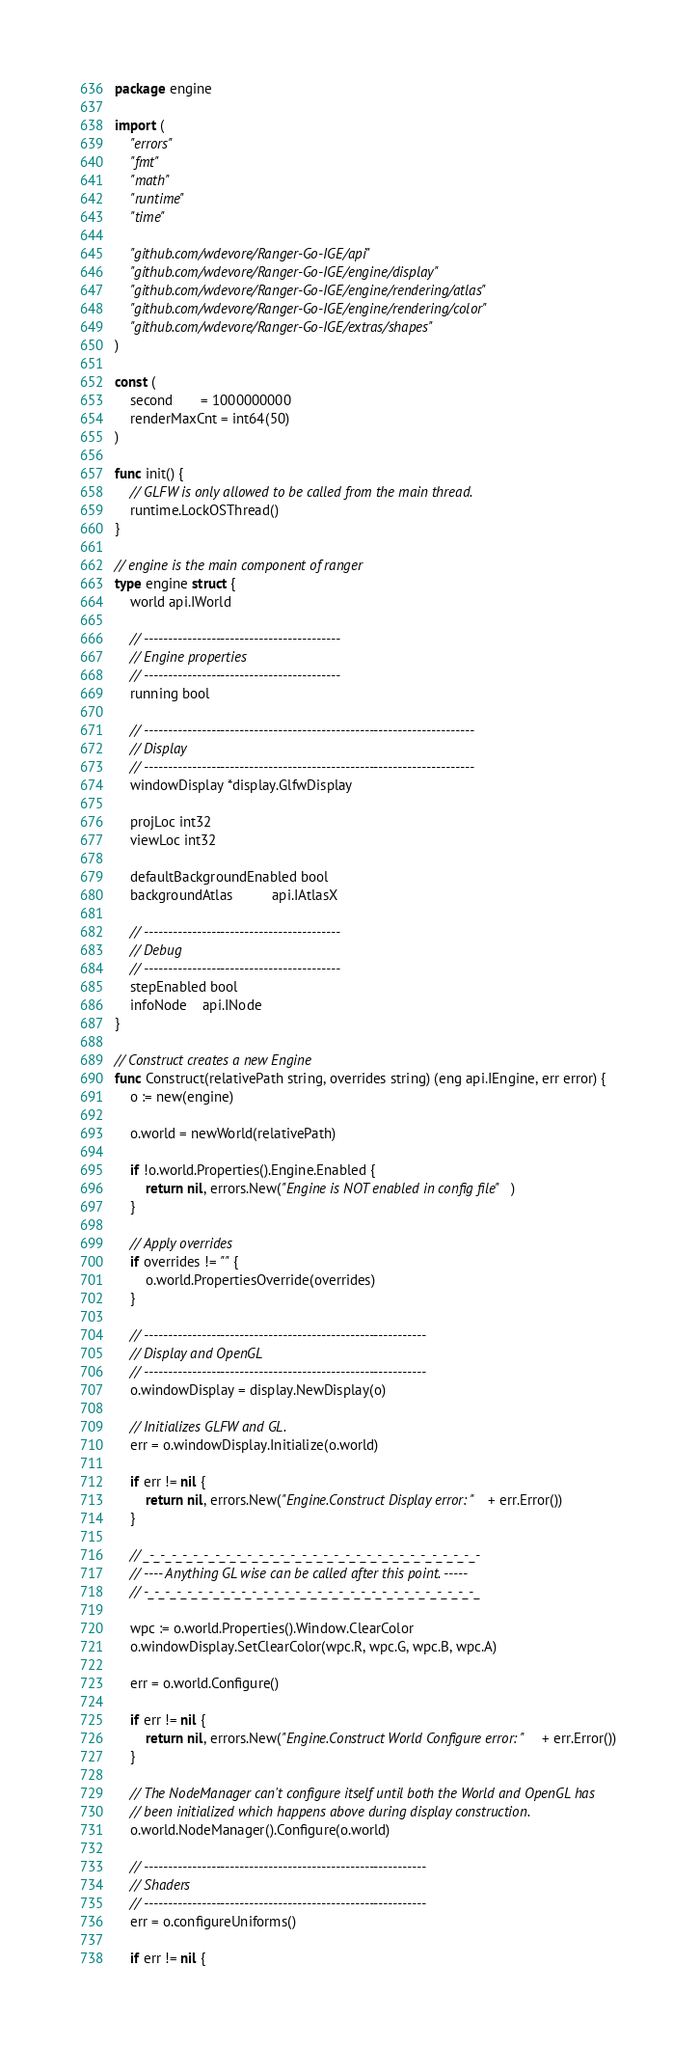Convert code to text. <code><loc_0><loc_0><loc_500><loc_500><_Go_>package engine

import (
	"errors"
	"fmt"
	"math"
	"runtime"
	"time"

	"github.com/wdevore/Ranger-Go-IGE/api"
	"github.com/wdevore/Ranger-Go-IGE/engine/display"
	"github.com/wdevore/Ranger-Go-IGE/engine/rendering/atlas"
	"github.com/wdevore/Ranger-Go-IGE/engine/rendering/color"
	"github.com/wdevore/Ranger-Go-IGE/extras/shapes"
)

const (
	second       = 1000000000
	renderMaxCnt = int64(50)
)

func init() {
	// GLFW is only allowed to be called from the main thread.
	runtime.LockOSThread()
}

// engine is the main component of ranger
type engine struct {
	world api.IWorld

	// -----------------------------------------
	// Engine properties
	// -----------------------------------------
	running bool

	// ---------------------------------------------------------------------
	// Display
	// ---------------------------------------------------------------------
	windowDisplay *display.GlfwDisplay

	projLoc int32
	viewLoc int32

	defaultBackgroundEnabled bool
	backgroundAtlas          api.IAtlasX

	// -----------------------------------------
	// Debug
	// -----------------------------------------
	stepEnabled bool
	infoNode    api.INode
}

// Construct creates a new Engine
func Construct(relativePath string, overrides string) (eng api.IEngine, err error) {
	o := new(engine)

	o.world = newWorld(relativePath)

	if !o.world.Properties().Engine.Enabled {
		return nil, errors.New("Engine is NOT enabled in config file")
	}

	// Apply overrides
	if overrides != "" {
		o.world.PropertiesOverride(overrides)
	}

	// -----------------------------------------------------------
	// Display and OpenGL
	// -----------------------------------------------------------
	o.windowDisplay = display.NewDisplay(o)

	// Initializes GLFW and GL.
	err = o.windowDisplay.Initialize(o.world)

	if err != nil {
		return nil, errors.New("Engine.Construct Display error: " + err.Error())
	}

	// _-_-_-_-_-_-_-_-_-_-_-_-_-_-_-_-_-_-_-_-_-_-_-_-_-_-_-_-_-_-_-
	// ---- Anything GL wise can be called after this point. -----
	// -_-_-_-_-_-_-_-_-_-_-_-_-_-_-_-_-_-_-_-_-_-_-_-_-_-_-_-_-_-_-_

	wpc := o.world.Properties().Window.ClearColor
	o.windowDisplay.SetClearColor(wpc.R, wpc.G, wpc.B, wpc.A)

	err = o.world.Configure()

	if err != nil {
		return nil, errors.New("Engine.Construct World Configure error: " + err.Error())
	}

	// The NodeManager can't configure itself until both the World and OpenGL has
	// been initialized which happens above during display construction.
	o.world.NodeManager().Configure(o.world)

	// -----------------------------------------------------------
	// Shaders
	// -----------------------------------------------------------
	err = o.configureUniforms()

	if err != nil {</code> 